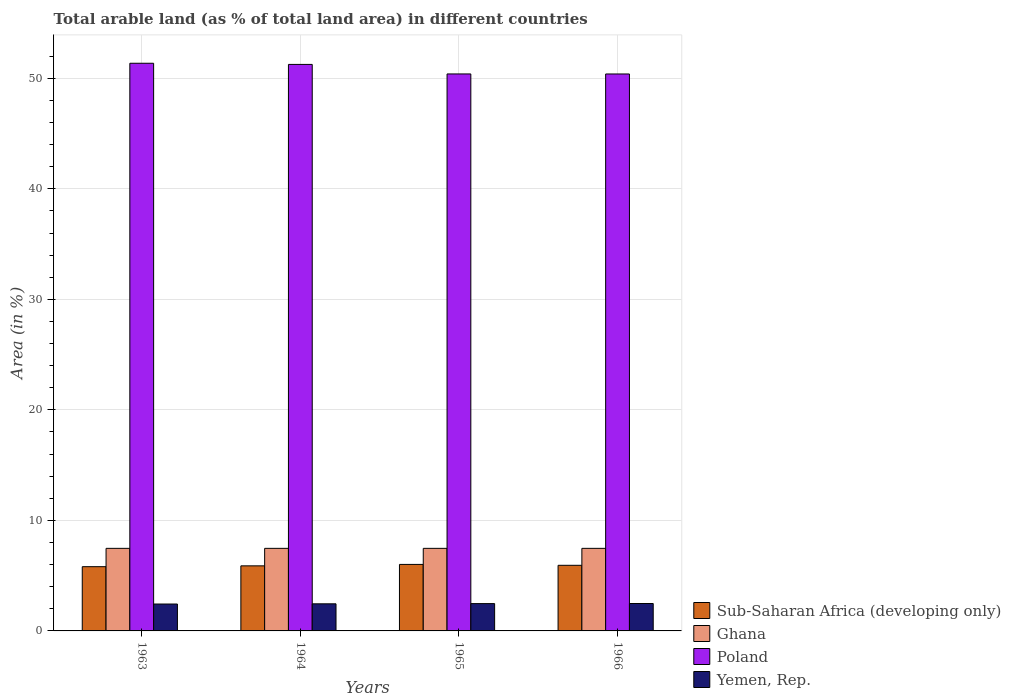Are the number of bars per tick equal to the number of legend labels?
Your answer should be very brief. Yes. How many bars are there on the 1st tick from the left?
Offer a terse response. 4. How many bars are there on the 3rd tick from the right?
Give a very brief answer. 4. What is the label of the 3rd group of bars from the left?
Keep it short and to the point. 1965. In how many cases, is the number of bars for a given year not equal to the number of legend labels?
Your answer should be very brief. 0. What is the percentage of arable land in Sub-Saharan Africa (developing only) in 1966?
Provide a succinct answer. 5.94. Across all years, what is the maximum percentage of arable land in Yemen, Rep.?
Your response must be concise. 2.48. Across all years, what is the minimum percentage of arable land in Ghana?
Provide a succinct answer. 7.47. In which year was the percentage of arable land in Yemen, Rep. maximum?
Provide a succinct answer. 1966. What is the total percentage of arable land in Yemen, Rep. in the graph?
Keep it short and to the point. 9.84. What is the difference between the percentage of arable land in Ghana in 1965 and that in 1966?
Provide a succinct answer. 0. What is the difference between the percentage of arable land in Poland in 1963 and the percentage of arable land in Ghana in 1964?
Make the answer very short. 43.9. What is the average percentage of arable land in Poland per year?
Ensure brevity in your answer.  50.86. In the year 1965, what is the difference between the percentage of arable land in Ghana and percentage of arable land in Sub-Saharan Africa (developing only)?
Make the answer very short. 1.45. In how many years, is the percentage of arable land in Ghana greater than 16 %?
Offer a very short reply. 0. What is the ratio of the percentage of arable land in Poland in 1963 to that in 1964?
Ensure brevity in your answer.  1. Is the percentage of arable land in Poland in 1963 less than that in 1966?
Ensure brevity in your answer.  No. Is the difference between the percentage of arable land in Ghana in 1963 and 1964 greater than the difference between the percentage of arable land in Sub-Saharan Africa (developing only) in 1963 and 1964?
Your response must be concise. Yes. What is the difference between the highest and the second highest percentage of arable land in Poland?
Give a very brief answer. 0.1. What is the difference between the highest and the lowest percentage of arable land in Sub-Saharan Africa (developing only)?
Keep it short and to the point. 0.21. Is the sum of the percentage of arable land in Yemen, Rep. in 1964 and 1966 greater than the maximum percentage of arable land in Sub-Saharan Africa (developing only) across all years?
Your answer should be compact. No. Is it the case that in every year, the sum of the percentage of arable land in Poland and percentage of arable land in Yemen, Rep. is greater than the sum of percentage of arable land in Sub-Saharan Africa (developing only) and percentage of arable land in Ghana?
Provide a short and direct response. Yes. What does the 2nd bar from the left in 1965 represents?
Your answer should be compact. Ghana. What does the 1st bar from the right in 1965 represents?
Keep it short and to the point. Yemen, Rep. Are all the bars in the graph horizontal?
Your answer should be very brief. No. How many years are there in the graph?
Give a very brief answer. 4. What is the difference between two consecutive major ticks on the Y-axis?
Ensure brevity in your answer.  10. Does the graph contain any zero values?
Provide a succinct answer. No. How are the legend labels stacked?
Provide a succinct answer. Vertical. What is the title of the graph?
Make the answer very short. Total arable land (as % of total land area) in different countries. Does "Uzbekistan" appear as one of the legend labels in the graph?
Give a very brief answer. No. What is the label or title of the Y-axis?
Your response must be concise. Area (in %). What is the Area (in %) of Sub-Saharan Africa (developing only) in 1963?
Make the answer very short. 5.81. What is the Area (in %) in Ghana in 1963?
Provide a short and direct response. 7.47. What is the Area (in %) in Poland in 1963?
Your answer should be very brief. 51.37. What is the Area (in %) in Yemen, Rep. in 1963?
Your response must be concise. 2.43. What is the Area (in %) in Sub-Saharan Africa (developing only) in 1964?
Offer a terse response. 5.89. What is the Area (in %) of Ghana in 1964?
Provide a short and direct response. 7.47. What is the Area (in %) of Poland in 1964?
Provide a short and direct response. 51.26. What is the Area (in %) of Yemen, Rep. in 1964?
Offer a very short reply. 2.45. What is the Area (in %) in Sub-Saharan Africa (developing only) in 1965?
Give a very brief answer. 6.02. What is the Area (in %) of Ghana in 1965?
Make the answer very short. 7.47. What is the Area (in %) in Poland in 1965?
Your answer should be compact. 50.4. What is the Area (in %) of Yemen, Rep. in 1965?
Provide a succinct answer. 2.47. What is the Area (in %) of Sub-Saharan Africa (developing only) in 1966?
Give a very brief answer. 5.94. What is the Area (in %) in Ghana in 1966?
Your answer should be compact. 7.47. What is the Area (in %) of Poland in 1966?
Your answer should be very brief. 50.4. What is the Area (in %) of Yemen, Rep. in 1966?
Your answer should be very brief. 2.48. Across all years, what is the maximum Area (in %) in Sub-Saharan Africa (developing only)?
Give a very brief answer. 6.02. Across all years, what is the maximum Area (in %) of Ghana?
Provide a short and direct response. 7.47. Across all years, what is the maximum Area (in %) in Poland?
Provide a succinct answer. 51.37. Across all years, what is the maximum Area (in %) of Yemen, Rep.?
Ensure brevity in your answer.  2.48. Across all years, what is the minimum Area (in %) of Sub-Saharan Africa (developing only)?
Make the answer very short. 5.81. Across all years, what is the minimum Area (in %) in Ghana?
Offer a very short reply. 7.47. Across all years, what is the minimum Area (in %) in Poland?
Keep it short and to the point. 50.4. Across all years, what is the minimum Area (in %) in Yemen, Rep.?
Offer a very short reply. 2.43. What is the total Area (in %) of Sub-Saharan Africa (developing only) in the graph?
Your answer should be very brief. 23.66. What is the total Area (in %) in Ghana in the graph?
Your response must be concise. 29.88. What is the total Area (in %) in Poland in the graph?
Provide a short and direct response. 203.42. What is the total Area (in %) in Yemen, Rep. in the graph?
Ensure brevity in your answer.  9.84. What is the difference between the Area (in %) of Sub-Saharan Africa (developing only) in 1963 and that in 1964?
Your answer should be very brief. -0.08. What is the difference between the Area (in %) in Ghana in 1963 and that in 1964?
Provide a short and direct response. 0. What is the difference between the Area (in %) in Poland in 1963 and that in 1964?
Offer a terse response. 0.1. What is the difference between the Area (in %) in Yemen, Rep. in 1963 and that in 1964?
Offer a very short reply. -0.02. What is the difference between the Area (in %) of Sub-Saharan Africa (developing only) in 1963 and that in 1965?
Your answer should be compact. -0.21. What is the difference between the Area (in %) in Poland in 1963 and that in 1965?
Offer a very short reply. 0.97. What is the difference between the Area (in %) in Yemen, Rep. in 1963 and that in 1965?
Provide a succinct answer. -0.04. What is the difference between the Area (in %) in Sub-Saharan Africa (developing only) in 1963 and that in 1966?
Your response must be concise. -0.12. What is the difference between the Area (in %) in Ghana in 1963 and that in 1966?
Your response must be concise. 0. What is the difference between the Area (in %) of Poland in 1963 and that in 1966?
Your answer should be compact. 0.97. What is the difference between the Area (in %) in Yemen, Rep. in 1963 and that in 1966?
Your answer should be compact. -0.05. What is the difference between the Area (in %) in Sub-Saharan Africa (developing only) in 1964 and that in 1965?
Provide a succinct answer. -0.13. What is the difference between the Area (in %) of Poland in 1964 and that in 1965?
Provide a succinct answer. 0.86. What is the difference between the Area (in %) of Yemen, Rep. in 1964 and that in 1965?
Keep it short and to the point. -0.02. What is the difference between the Area (in %) of Sub-Saharan Africa (developing only) in 1964 and that in 1966?
Offer a terse response. -0.05. What is the difference between the Area (in %) in Ghana in 1964 and that in 1966?
Offer a very short reply. 0. What is the difference between the Area (in %) of Poland in 1964 and that in 1966?
Offer a terse response. 0.87. What is the difference between the Area (in %) in Yemen, Rep. in 1964 and that in 1966?
Provide a short and direct response. -0.03. What is the difference between the Area (in %) of Sub-Saharan Africa (developing only) in 1965 and that in 1966?
Your answer should be very brief. 0.08. What is the difference between the Area (in %) of Poland in 1965 and that in 1966?
Keep it short and to the point. 0. What is the difference between the Area (in %) in Yemen, Rep. in 1965 and that in 1966?
Your answer should be very brief. -0.01. What is the difference between the Area (in %) of Sub-Saharan Africa (developing only) in 1963 and the Area (in %) of Ghana in 1964?
Give a very brief answer. -1.66. What is the difference between the Area (in %) of Sub-Saharan Africa (developing only) in 1963 and the Area (in %) of Poland in 1964?
Your answer should be compact. -45.45. What is the difference between the Area (in %) in Sub-Saharan Africa (developing only) in 1963 and the Area (in %) in Yemen, Rep. in 1964?
Ensure brevity in your answer.  3.36. What is the difference between the Area (in %) of Ghana in 1963 and the Area (in %) of Poland in 1964?
Offer a very short reply. -43.79. What is the difference between the Area (in %) of Ghana in 1963 and the Area (in %) of Yemen, Rep. in 1964?
Your response must be concise. 5.02. What is the difference between the Area (in %) of Poland in 1963 and the Area (in %) of Yemen, Rep. in 1964?
Give a very brief answer. 48.91. What is the difference between the Area (in %) of Sub-Saharan Africa (developing only) in 1963 and the Area (in %) of Ghana in 1965?
Your answer should be very brief. -1.66. What is the difference between the Area (in %) of Sub-Saharan Africa (developing only) in 1963 and the Area (in %) of Poland in 1965?
Keep it short and to the point. -44.59. What is the difference between the Area (in %) of Sub-Saharan Africa (developing only) in 1963 and the Area (in %) of Yemen, Rep. in 1965?
Offer a very short reply. 3.34. What is the difference between the Area (in %) of Ghana in 1963 and the Area (in %) of Poland in 1965?
Provide a short and direct response. -42.93. What is the difference between the Area (in %) of Ghana in 1963 and the Area (in %) of Yemen, Rep. in 1965?
Offer a terse response. 5. What is the difference between the Area (in %) of Poland in 1963 and the Area (in %) of Yemen, Rep. in 1965?
Your response must be concise. 48.89. What is the difference between the Area (in %) of Sub-Saharan Africa (developing only) in 1963 and the Area (in %) of Ghana in 1966?
Provide a short and direct response. -1.66. What is the difference between the Area (in %) of Sub-Saharan Africa (developing only) in 1963 and the Area (in %) of Poland in 1966?
Provide a short and direct response. -44.58. What is the difference between the Area (in %) in Sub-Saharan Africa (developing only) in 1963 and the Area (in %) in Yemen, Rep. in 1966?
Make the answer very short. 3.33. What is the difference between the Area (in %) of Ghana in 1963 and the Area (in %) of Poland in 1966?
Keep it short and to the point. -42.93. What is the difference between the Area (in %) in Ghana in 1963 and the Area (in %) in Yemen, Rep. in 1966?
Keep it short and to the point. 4.99. What is the difference between the Area (in %) of Poland in 1963 and the Area (in %) of Yemen, Rep. in 1966?
Your answer should be very brief. 48.89. What is the difference between the Area (in %) in Sub-Saharan Africa (developing only) in 1964 and the Area (in %) in Ghana in 1965?
Make the answer very short. -1.58. What is the difference between the Area (in %) in Sub-Saharan Africa (developing only) in 1964 and the Area (in %) in Poland in 1965?
Your response must be concise. -44.51. What is the difference between the Area (in %) of Sub-Saharan Africa (developing only) in 1964 and the Area (in %) of Yemen, Rep. in 1965?
Give a very brief answer. 3.42. What is the difference between the Area (in %) in Ghana in 1964 and the Area (in %) in Poland in 1965?
Ensure brevity in your answer.  -42.93. What is the difference between the Area (in %) of Ghana in 1964 and the Area (in %) of Yemen, Rep. in 1965?
Keep it short and to the point. 5. What is the difference between the Area (in %) in Poland in 1964 and the Area (in %) in Yemen, Rep. in 1965?
Make the answer very short. 48.79. What is the difference between the Area (in %) of Sub-Saharan Africa (developing only) in 1964 and the Area (in %) of Ghana in 1966?
Provide a short and direct response. -1.58. What is the difference between the Area (in %) of Sub-Saharan Africa (developing only) in 1964 and the Area (in %) of Poland in 1966?
Make the answer very short. -44.51. What is the difference between the Area (in %) in Sub-Saharan Africa (developing only) in 1964 and the Area (in %) in Yemen, Rep. in 1966?
Your answer should be very brief. 3.41. What is the difference between the Area (in %) of Ghana in 1964 and the Area (in %) of Poland in 1966?
Ensure brevity in your answer.  -42.93. What is the difference between the Area (in %) in Ghana in 1964 and the Area (in %) in Yemen, Rep. in 1966?
Offer a terse response. 4.99. What is the difference between the Area (in %) of Poland in 1964 and the Area (in %) of Yemen, Rep. in 1966?
Give a very brief answer. 48.78. What is the difference between the Area (in %) of Sub-Saharan Africa (developing only) in 1965 and the Area (in %) of Ghana in 1966?
Provide a succinct answer. -1.45. What is the difference between the Area (in %) of Sub-Saharan Africa (developing only) in 1965 and the Area (in %) of Poland in 1966?
Provide a short and direct response. -44.38. What is the difference between the Area (in %) in Sub-Saharan Africa (developing only) in 1965 and the Area (in %) in Yemen, Rep. in 1966?
Offer a terse response. 3.54. What is the difference between the Area (in %) of Ghana in 1965 and the Area (in %) of Poland in 1966?
Your answer should be compact. -42.93. What is the difference between the Area (in %) in Ghana in 1965 and the Area (in %) in Yemen, Rep. in 1966?
Offer a terse response. 4.99. What is the difference between the Area (in %) in Poland in 1965 and the Area (in %) in Yemen, Rep. in 1966?
Offer a very short reply. 47.92. What is the average Area (in %) in Sub-Saharan Africa (developing only) per year?
Make the answer very short. 5.91. What is the average Area (in %) in Ghana per year?
Your response must be concise. 7.47. What is the average Area (in %) of Poland per year?
Your answer should be compact. 50.86. What is the average Area (in %) of Yemen, Rep. per year?
Your answer should be compact. 2.46. In the year 1963, what is the difference between the Area (in %) of Sub-Saharan Africa (developing only) and Area (in %) of Ghana?
Provide a succinct answer. -1.66. In the year 1963, what is the difference between the Area (in %) of Sub-Saharan Africa (developing only) and Area (in %) of Poland?
Your answer should be very brief. -45.55. In the year 1963, what is the difference between the Area (in %) in Sub-Saharan Africa (developing only) and Area (in %) in Yemen, Rep.?
Provide a succinct answer. 3.38. In the year 1963, what is the difference between the Area (in %) in Ghana and Area (in %) in Poland?
Your answer should be very brief. -43.9. In the year 1963, what is the difference between the Area (in %) in Ghana and Area (in %) in Yemen, Rep.?
Provide a succinct answer. 5.04. In the year 1963, what is the difference between the Area (in %) of Poland and Area (in %) of Yemen, Rep.?
Keep it short and to the point. 48.93. In the year 1964, what is the difference between the Area (in %) in Sub-Saharan Africa (developing only) and Area (in %) in Ghana?
Make the answer very short. -1.58. In the year 1964, what is the difference between the Area (in %) of Sub-Saharan Africa (developing only) and Area (in %) of Poland?
Your response must be concise. -45.37. In the year 1964, what is the difference between the Area (in %) in Sub-Saharan Africa (developing only) and Area (in %) in Yemen, Rep.?
Provide a succinct answer. 3.44. In the year 1964, what is the difference between the Area (in %) in Ghana and Area (in %) in Poland?
Provide a short and direct response. -43.79. In the year 1964, what is the difference between the Area (in %) in Ghana and Area (in %) in Yemen, Rep.?
Your response must be concise. 5.02. In the year 1964, what is the difference between the Area (in %) in Poland and Area (in %) in Yemen, Rep.?
Your answer should be compact. 48.81. In the year 1965, what is the difference between the Area (in %) in Sub-Saharan Africa (developing only) and Area (in %) in Ghana?
Your response must be concise. -1.45. In the year 1965, what is the difference between the Area (in %) of Sub-Saharan Africa (developing only) and Area (in %) of Poland?
Offer a very short reply. -44.38. In the year 1965, what is the difference between the Area (in %) of Sub-Saharan Africa (developing only) and Area (in %) of Yemen, Rep.?
Your response must be concise. 3.55. In the year 1965, what is the difference between the Area (in %) of Ghana and Area (in %) of Poland?
Provide a short and direct response. -42.93. In the year 1965, what is the difference between the Area (in %) of Ghana and Area (in %) of Yemen, Rep.?
Keep it short and to the point. 5. In the year 1965, what is the difference between the Area (in %) of Poland and Area (in %) of Yemen, Rep.?
Your response must be concise. 47.93. In the year 1966, what is the difference between the Area (in %) in Sub-Saharan Africa (developing only) and Area (in %) in Ghana?
Give a very brief answer. -1.53. In the year 1966, what is the difference between the Area (in %) in Sub-Saharan Africa (developing only) and Area (in %) in Poland?
Give a very brief answer. -44.46. In the year 1966, what is the difference between the Area (in %) in Sub-Saharan Africa (developing only) and Area (in %) in Yemen, Rep.?
Make the answer very short. 3.46. In the year 1966, what is the difference between the Area (in %) of Ghana and Area (in %) of Poland?
Your answer should be compact. -42.93. In the year 1966, what is the difference between the Area (in %) of Ghana and Area (in %) of Yemen, Rep.?
Offer a terse response. 4.99. In the year 1966, what is the difference between the Area (in %) of Poland and Area (in %) of Yemen, Rep.?
Keep it short and to the point. 47.92. What is the ratio of the Area (in %) of Sub-Saharan Africa (developing only) in 1963 to that in 1964?
Provide a short and direct response. 0.99. What is the ratio of the Area (in %) of Ghana in 1963 to that in 1964?
Provide a succinct answer. 1. What is the ratio of the Area (in %) of Poland in 1963 to that in 1964?
Make the answer very short. 1. What is the ratio of the Area (in %) of Sub-Saharan Africa (developing only) in 1963 to that in 1965?
Offer a terse response. 0.97. What is the ratio of the Area (in %) of Ghana in 1963 to that in 1965?
Your answer should be very brief. 1. What is the ratio of the Area (in %) of Poland in 1963 to that in 1965?
Give a very brief answer. 1.02. What is the ratio of the Area (in %) in Yemen, Rep. in 1963 to that in 1965?
Offer a very short reply. 0.98. What is the ratio of the Area (in %) in Ghana in 1963 to that in 1966?
Make the answer very short. 1. What is the ratio of the Area (in %) of Poland in 1963 to that in 1966?
Your response must be concise. 1.02. What is the ratio of the Area (in %) in Yemen, Rep. in 1963 to that in 1966?
Keep it short and to the point. 0.98. What is the ratio of the Area (in %) of Sub-Saharan Africa (developing only) in 1964 to that in 1965?
Your answer should be compact. 0.98. What is the ratio of the Area (in %) in Poland in 1964 to that in 1965?
Offer a very short reply. 1.02. What is the ratio of the Area (in %) in Yemen, Rep. in 1964 to that in 1965?
Your answer should be compact. 0.99. What is the ratio of the Area (in %) of Ghana in 1964 to that in 1966?
Make the answer very short. 1. What is the ratio of the Area (in %) of Poland in 1964 to that in 1966?
Provide a succinct answer. 1.02. What is the ratio of the Area (in %) of Yemen, Rep. in 1964 to that in 1966?
Your answer should be very brief. 0.99. What is the ratio of the Area (in %) of Sub-Saharan Africa (developing only) in 1965 to that in 1966?
Your answer should be compact. 1.01. What is the difference between the highest and the second highest Area (in %) in Sub-Saharan Africa (developing only)?
Ensure brevity in your answer.  0.08. What is the difference between the highest and the second highest Area (in %) of Ghana?
Give a very brief answer. 0. What is the difference between the highest and the second highest Area (in %) in Poland?
Your answer should be compact. 0.1. What is the difference between the highest and the second highest Area (in %) in Yemen, Rep.?
Keep it short and to the point. 0.01. What is the difference between the highest and the lowest Area (in %) of Sub-Saharan Africa (developing only)?
Offer a very short reply. 0.21. What is the difference between the highest and the lowest Area (in %) of Ghana?
Offer a terse response. 0. What is the difference between the highest and the lowest Area (in %) in Poland?
Your answer should be compact. 0.97. What is the difference between the highest and the lowest Area (in %) in Yemen, Rep.?
Provide a succinct answer. 0.05. 